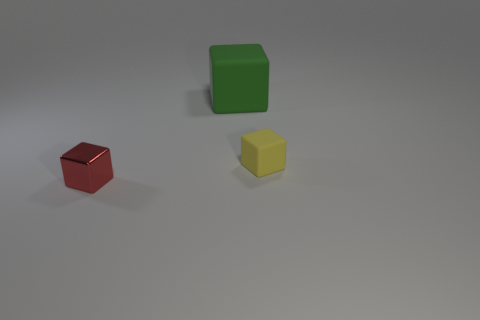Do the red metal thing and the yellow matte object have the same size?
Your answer should be compact. Yes. What color is the other thing that is the same size as the yellow thing?
Your answer should be very brief. Red. Are any large brown metallic cylinders visible?
Provide a short and direct response. No. There is a tiny block that is behind the red block; how many cubes are in front of it?
Provide a short and direct response. 1. The object to the left of the big thing has what shape?
Your response must be concise. Cube. The tiny object that is behind the thing that is left of the matte block behind the tiny yellow thing is made of what material?
Provide a succinct answer. Rubber. What number of other things are there of the same size as the red shiny block?
Provide a succinct answer. 1. There is a tiny yellow thing that is the same shape as the large green thing; what is its material?
Offer a terse response. Rubber. What is the color of the big rubber object?
Offer a terse response. Green. There is a matte object that is behind the rubber object that is to the right of the large thing; what is its color?
Make the answer very short. Green. 